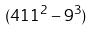Convert formula to latex. <formula><loc_0><loc_0><loc_500><loc_500>( 4 1 1 ^ { 2 } - 9 ^ { 3 } )</formula> 